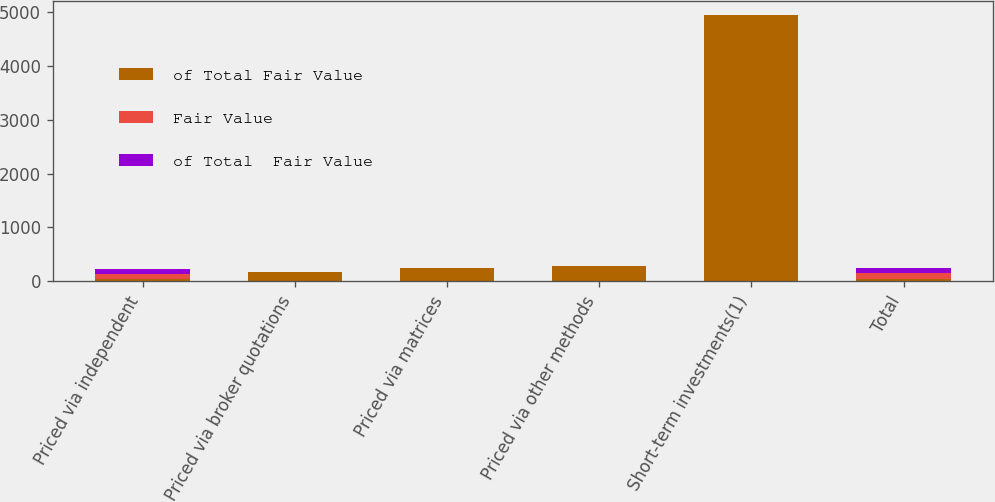Convert chart. <chart><loc_0><loc_0><loc_500><loc_500><stacked_bar_chart><ecel><fcel>Priced via independent<fcel>Priced via broker quotations<fcel>Priced via matrices<fcel>Priced via other methods<fcel>Short-term investments(1)<fcel>Total<nl><fcel>of Total Fair Value<fcel>49.5<fcel>173<fcel>255<fcel>292<fcel>4938<fcel>49.5<nl><fcel>Fair Value<fcel>91.6<fcel>0.3<fcel>0.4<fcel>0.4<fcel>7.3<fcel>100<nl><fcel>of Total  Fair Value<fcel>91.5<fcel>0.3<fcel>0.3<fcel>0.4<fcel>7.5<fcel>100<nl></chart> 